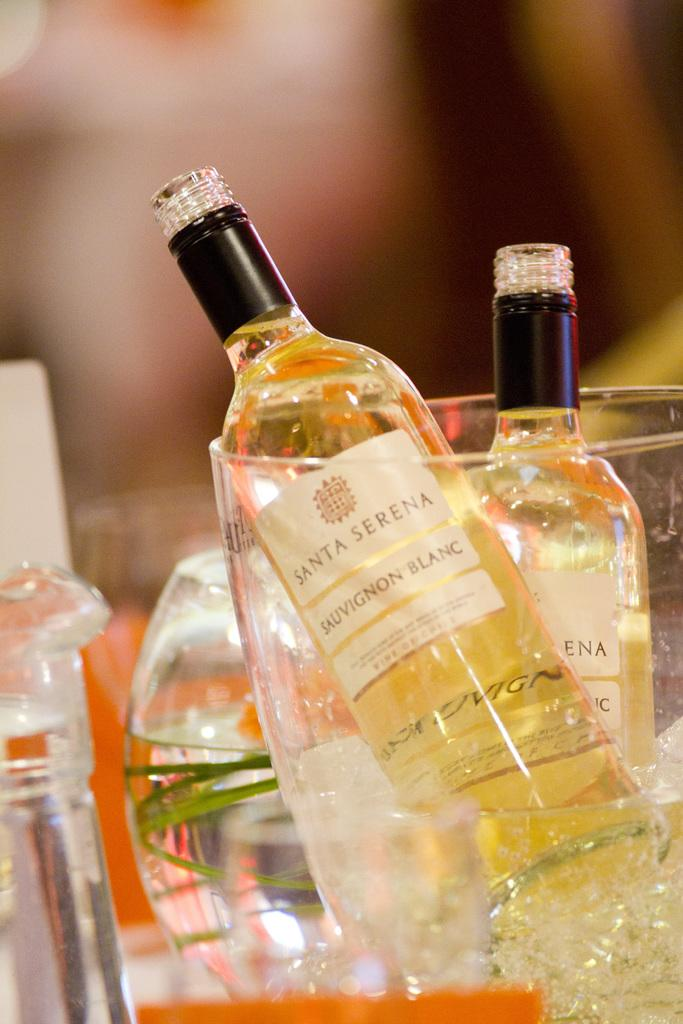<image>
Summarize the visual content of the image. A bottle of Santa Serena sauvignon blanc sits in an ice bucket. 